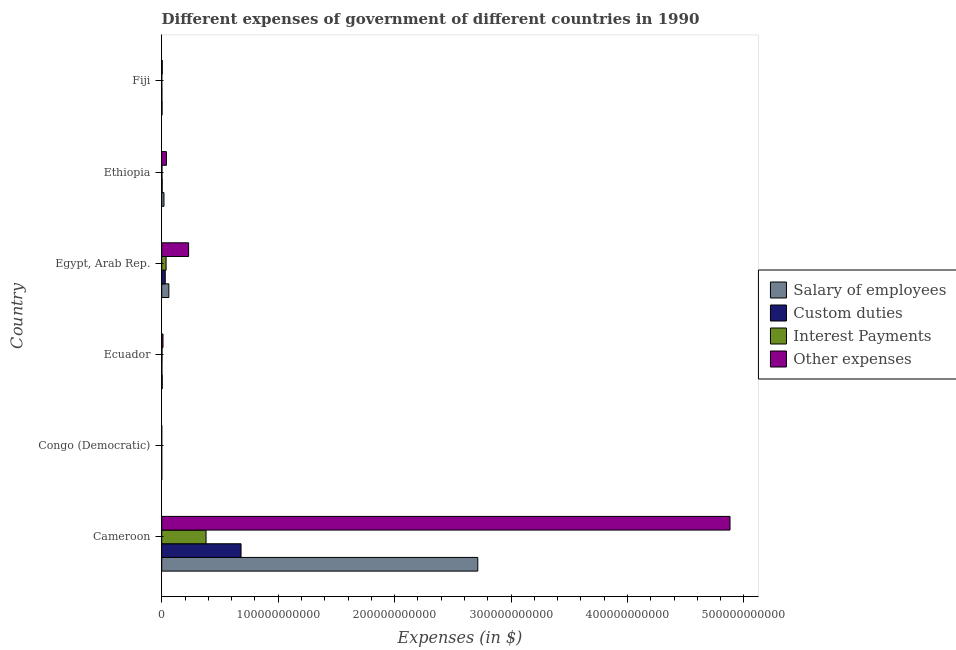Are the number of bars on each tick of the Y-axis equal?
Provide a succinct answer. Yes. What is the label of the 2nd group of bars from the top?
Your answer should be compact. Ethiopia. In how many cases, is the number of bars for a given country not equal to the number of legend labels?
Your answer should be very brief. 0. What is the amount spent on other expenses in Congo (Democratic)?
Keep it short and to the point. 3.74. Across all countries, what is the maximum amount spent on custom duties?
Offer a very short reply. 6.81e+1. Across all countries, what is the minimum amount spent on other expenses?
Your answer should be very brief. 3.74. In which country was the amount spent on custom duties maximum?
Ensure brevity in your answer.  Cameroon. In which country was the amount spent on interest payments minimum?
Offer a terse response. Congo (Democratic). What is the total amount spent on interest payments in the graph?
Your answer should be very brief. 4.24e+1. What is the difference between the amount spent on other expenses in Cameroon and that in Egypt, Arab Rep.?
Provide a short and direct response. 4.65e+11. What is the difference between the amount spent on custom duties in Ecuador and the amount spent on other expenses in Egypt, Arab Rep.?
Offer a very short reply. -2.29e+1. What is the average amount spent on other expenses per country?
Keep it short and to the point. 8.61e+1. What is the difference between the amount spent on custom duties and amount spent on interest payments in Ecuador?
Your response must be concise. -1.00e+08. What is the ratio of the amount spent on custom duties in Egypt, Arab Rep. to that in Fiji?
Offer a terse response. 19.52. Is the amount spent on salary of employees in Congo (Democratic) less than that in Egypt, Arab Rep.?
Your response must be concise. Yes. Is the difference between the amount spent on custom duties in Cameroon and Ethiopia greater than the difference between the amount spent on salary of employees in Cameroon and Ethiopia?
Keep it short and to the point. No. What is the difference between the highest and the second highest amount spent on custom duties?
Provide a short and direct response. 6.51e+1. What is the difference between the highest and the lowest amount spent on custom duties?
Your answer should be compact. 6.81e+1. What does the 4th bar from the top in Ecuador represents?
Provide a succinct answer. Salary of employees. What does the 3rd bar from the bottom in Ecuador represents?
Provide a short and direct response. Interest Payments. How many countries are there in the graph?
Provide a succinct answer. 6. What is the difference between two consecutive major ticks on the X-axis?
Offer a terse response. 1.00e+11. Are the values on the major ticks of X-axis written in scientific E-notation?
Your answer should be compact. No. What is the title of the graph?
Give a very brief answer. Different expenses of government of different countries in 1990. Does "Manufacturing" appear as one of the legend labels in the graph?
Offer a very short reply. No. What is the label or title of the X-axis?
Provide a succinct answer. Expenses (in $). What is the Expenses (in $) in Salary of employees in Cameroon?
Your answer should be very brief. 2.71e+11. What is the Expenses (in $) in Custom duties in Cameroon?
Offer a terse response. 6.81e+1. What is the Expenses (in $) of Interest Payments in Cameroon?
Keep it short and to the point. 3.81e+1. What is the Expenses (in $) of Other expenses in Cameroon?
Offer a terse response. 4.88e+11. What is the Expenses (in $) in Salary of employees in Congo (Democratic)?
Your answer should be compact. 0.95. What is the Expenses (in $) in Custom duties in Congo (Democratic)?
Ensure brevity in your answer.  0.95. What is the Expenses (in $) in Interest Payments in Congo (Democratic)?
Ensure brevity in your answer.  0.28. What is the Expenses (in $) of Other expenses in Congo (Democratic)?
Provide a short and direct response. 3.74. What is the Expenses (in $) in Salary of employees in Ecuador?
Your answer should be compact. 4.52e+08. What is the Expenses (in $) in Custom duties in Ecuador?
Ensure brevity in your answer.  1.76e+08. What is the Expenses (in $) of Interest Payments in Ecuador?
Give a very brief answer. 2.76e+08. What is the Expenses (in $) in Other expenses in Ecuador?
Give a very brief answer. 1.11e+09. What is the Expenses (in $) in Salary of employees in Egypt, Arab Rep.?
Your response must be concise. 6.14e+09. What is the Expenses (in $) of Custom duties in Egypt, Arab Rep.?
Offer a very short reply. 3.04e+09. What is the Expenses (in $) of Interest Payments in Egypt, Arab Rep.?
Offer a very short reply. 3.76e+09. What is the Expenses (in $) of Other expenses in Egypt, Arab Rep.?
Your answer should be very brief. 2.31e+1. What is the Expenses (in $) in Salary of employees in Ethiopia?
Make the answer very short. 1.95e+09. What is the Expenses (in $) of Custom duties in Ethiopia?
Your answer should be very brief. 3.91e+08. What is the Expenses (in $) of Interest Payments in Ethiopia?
Keep it short and to the point. 2.28e+08. What is the Expenses (in $) in Other expenses in Ethiopia?
Provide a short and direct response. 4.05e+09. What is the Expenses (in $) of Salary of employees in Fiji?
Provide a succinct answer. 3.04e+08. What is the Expenses (in $) of Custom duties in Fiji?
Your answer should be very brief. 1.56e+08. What is the Expenses (in $) of Interest Payments in Fiji?
Provide a short and direct response. 6.85e+07. What is the Expenses (in $) of Other expenses in Fiji?
Ensure brevity in your answer.  4.74e+08. Across all countries, what is the maximum Expenses (in $) in Salary of employees?
Your answer should be very brief. 2.71e+11. Across all countries, what is the maximum Expenses (in $) of Custom duties?
Provide a succinct answer. 6.81e+1. Across all countries, what is the maximum Expenses (in $) of Interest Payments?
Provide a short and direct response. 3.81e+1. Across all countries, what is the maximum Expenses (in $) of Other expenses?
Provide a succinct answer. 4.88e+11. Across all countries, what is the minimum Expenses (in $) of Salary of employees?
Your response must be concise. 0.95. Across all countries, what is the minimum Expenses (in $) in Custom duties?
Offer a very short reply. 0.95. Across all countries, what is the minimum Expenses (in $) in Interest Payments?
Give a very brief answer. 0.28. Across all countries, what is the minimum Expenses (in $) in Other expenses?
Your response must be concise. 3.74. What is the total Expenses (in $) in Salary of employees in the graph?
Offer a very short reply. 2.80e+11. What is the total Expenses (in $) in Custom duties in the graph?
Keep it short and to the point. 7.19e+1. What is the total Expenses (in $) in Interest Payments in the graph?
Make the answer very short. 4.24e+1. What is the total Expenses (in $) of Other expenses in the graph?
Your answer should be compact. 5.17e+11. What is the difference between the Expenses (in $) in Salary of employees in Cameroon and that in Congo (Democratic)?
Your answer should be very brief. 2.71e+11. What is the difference between the Expenses (in $) of Custom duties in Cameroon and that in Congo (Democratic)?
Offer a very short reply. 6.81e+1. What is the difference between the Expenses (in $) in Interest Payments in Cameroon and that in Congo (Democratic)?
Offer a very short reply. 3.81e+1. What is the difference between the Expenses (in $) of Other expenses in Cameroon and that in Congo (Democratic)?
Keep it short and to the point. 4.88e+11. What is the difference between the Expenses (in $) of Salary of employees in Cameroon and that in Ecuador?
Your response must be concise. 2.71e+11. What is the difference between the Expenses (in $) in Custom duties in Cameroon and that in Ecuador?
Your response must be concise. 6.80e+1. What is the difference between the Expenses (in $) of Interest Payments in Cameroon and that in Ecuador?
Provide a short and direct response. 3.78e+1. What is the difference between the Expenses (in $) in Other expenses in Cameroon and that in Ecuador?
Give a very brief answer. 4.87e+11. What is the difference between the Expenses (in $) of Salary of employees in Cameroon and that in Egypt, Arab Rep.?
Your answer should be compact. 2.65e+11. What is the difference between the Expenses (in $) of Custom duties in Cameroon and that in Egypt, Arab Rep.?
Provide a succinct answer. 6.51e+1. What is the difference between the Expenses (in $) of Interest Payments in Cameroon and that in Egypt, Arab Rep.?
Ensure brevity in your answer.  3.43e+1. What is the difference between the Expenses (in $) of Other expenses in Cameroon and that in Egypt, Arab Rep.?
Offer a very short reply. 4.65e+11. What is the difference between the Expenses (in $) in Salary of employees in Cameroon and that in Ethiopia?
Your response must be concise. 2.69e+11. What is the difference between the Expenses (in $) of Custom duties in Cameroon and that in Ethiopia?
Provide a short and direct response. 6.77e+1. What is the difference between the Expenses (in $) in Interest Payments in Cameroon and that in Ethiopia?
Give a very brief answer. 3.79e+1. What is the difference between the Expenses (in $) in Other expenses in Cameroon and that in Ethiopia?
Your answer should be compact. 4.84e+11. What is the difference between the Expenses (in $) of Salary of employees in Cameroon and that in Fiji?
Provide a succinct answer. 2.71e+11. What is the difference between the Expenses (in $) in Custom duties in Cameroon and that in Fiji?
Your answer should be compact. 6.80e+1. What is the difference between the Expenses (in $) of Interest Payments in Cameroon and that in Fiji?
Provide a succinct answer. 3.80e+1. What is the difference between the Expenses (in $) of Other expenses in Cameroon and that in Fiji?
Offer a terse response. 4.88e+11. What is the difference between the Expenses (in $) in Salary of employees in Congo (Democratic) and that in Ecuador?
Give a very brief answer. -4.52e+08. What is the difference between the Expenses (in $) in Custom duties in Congo (Democratic) and that in Ecuador?
Your answer should be very brief. -1.76e+08. What is the difference between the Expenses (in $) in Interest Payments in Congo (Democratic) and that in Ecuador?
Provide a succinct answer. -2.76e+08. What is the difference between the Expenses (in $) in Other expenses in Congo (Democratic) and that in Ecuador?
Your answer should be compact. -1.11e+09. What is the difference between the Expenses (in $) of Salary of employees in Congo (Democratic) and that in Egypt, Arab Rep.?
Provide a short and direct response. -6.13e+09. What is the difference between the Expenses (in $) in Custom duties in Congo (Democratic) and that in Egypt, Arab Rep.?
Keep it short and to the point. -3.04e+09. What is the difference between the Expenses (in $) of Interest Payments in Congo (Democratic) and that in Egypt, Arab Rep.?
Keep it short and to the point. -3.76e+09. What is the difference between the Expenses (in $) of Other expenses in Congo (Democratic) and that in Egypt, Arab Rep.?
Your answer should be compact. -2.31e+1. What is the difference between the Expenses (in $) in Salary of employees in Congo (Democratic) and that in Ethiopia?
Your response must be concise. -1.95e+09. What is the difference between the Expenses (in $) in Custom duties in Congo (Democratic) and that in Ethiopia?
Offer a very short reply. -3.91e+08. What is the difference between the Expenses (in $) of Interest Payments in Congo (Democratic) and that in Ethiopia?
Your answer should be compact. -2.28e+08. What is the difference between the Expenses (in $) of Other expenses in Congo (Democratic) and that in Ethiopia?
Provide a succinct answer. -4.05e+09. What is the difference between the Expenses (in $) of Salary of employees in Congo (Democratic) and that in Fiji?
Make the answer very short. -3.04e+08. What is the difference between the Expenses (in $) in Custom duties in Congo (Democratic) and that in Fiji?
Give a very brief answer. -1.56e+08. What is the difference between the Expenses (in $) in Interest Payments in Congo (Democratic) and that in Fiji?
Offer a terse response. -6.85e+07. What is the difference between the Expenses (in $) of Other expenses in Congo (Democratic) and that in Fiji?
Offer a terse response. -4.74e+08. What is the difference between the Expenses (in $) in Salary of employees in Ecuador and that in Egypt, Arab Rep.?
Make the answer very short. -5.68e+09. What is the difference between the Expenses (in $) of Custom duties in Ecuador and that in Egypt, Arab Rep.?
Your answer should be compact. -2.86e+09. What is the difference between the Expenses (in $) in Interest Payments in Ecuador and that in Egypt, Arab Rep.?
Make the answer very short. -3.48e+09. What is the difference between the Expenses (in $) of Other expenses in Ecuador and that in Egypt, Arab Rep.?
Your answer should be very brief. -2.20e+1. What is the difference between the Expenses (in $) in Salary of employees in Ecuador and that in Ethiopia?
Your answer should be compact. -1.50e+09. What is the difference between the Expenses (in $) in Custom duties in Ecuador and that in Ethiopia?
Your answer should be very brief. -2.15e+08. What is the difference between the Expenses (in $) in Interest Payments in Ecuador and that in Ethiopia?
Give a very brief answer. 4.83e+07. What is the difference between the Expenses (in $) of Other expenses in Ecuador and that in Ethiopia?
Your answer should be very brief. -2.94e+09. What is the difference between the Expenses (in $) of Salary of employees in Ecuador and that in Fiji?
Make the answer very short. 1.48e+08. What is the difference between the Expenses (in $) of Custom duties in Ecuador and that in Fiji?
Offer a terse response. 2.04e+07. What is the difference between the Expenses (in $) of Interest Payments in Ecuador and that in Fiji?
Your answer should be very brief. 2.07e+08. What is the difference between the Expenses (in $) in Other expenses in Ecuador and that in Fiji?
Ensure brevity in your answer.  6.37e+08. What is the difference between the Expenses (in $) of Salary of employees in Egypt, Arab Rep. and that in Ethiopia?
Ensure brevity in your answer.  4.18e+09. What is the difference between the Expenses (in $) of Custom duties in Egypt, Arab Rep. and that in Ethiopia?
Your response must be concise. 2.65e+09. What is the difference between the Expenses (in $) of Interest Payments in Egypt, Arab Rep. and that in Ethiopia?
Keep it short and to the point. 3.53e+09. What is the difference between the Expenses (in $) in Other expenses in Egypt, Arab Rep. and that in Ethiopia?
Your answer should be very brief. 1.90e+1. What is the difference between the Expenses (in $) in Salary of employees in Egypt, Arab Rep. and that in Fiji?
Your answer should be very brief. 5.83e+09. What is the difference between the Expenses (in $) of Custom duties in Egypt, Arab Rep. and that in Fiji?
Make the answer very short. 2.88e+09. What is the difference between the Expenses (in $) of Interest Payments in Egypt, Arab Rep. and that in Fiji?
Ensure brevity in your answer.  3.69e+09. What is the difference between the Expenses (in $) of Other expenses in Egypt, Arab Rep. and that in Fiji?
Offer a very short reply. 2.26e+1. What is the difference between the Expenses (in $) of Salary of employees in Ethiopia and that in Fiji?
Offer a very short reply. 1.65e+09. What is the difference between the Expenses (in $) of Custom duties in Ethiopia and that in Fiji?
Keep it short and to the point. 2.36e+08. What is the difference between the Expenses (in $) in Interest Payments in Ethiopia and that in Fiji?
Offer a very short reply. 1.59e+08. What is the difference between the Expenses (in $) in Other expenses in Ethiopia and that in Fiji?
Offer a very short reply. 3.58e+09. What is the difference between the Expenses (in $) of Salary of employees in Cameroon and the Expenses (in $) of Custom duties in Congo (Democratic)?
Keep it short and to the point. 2.71e+11. What is the difference between the Expenses (in $) in Salary of employees in Cameroon and the Expenses (in $) in Interest Payments in Congo (Democratic)?
Keep it short and to the point. 2.71e+11. What is the difference between the Expenses (in $) in Salary of employees in Cameroon and the Expenses (in $) in Other expenses in Congo (Democratic)?
Keep it short and to the point. 2.71e+11. What is the difference between the Expenses (in $) in Custom duties in Cameroon and the Expenses (in $) in Interest Payments in Congo (Democratic)?
Give a very brief answer. 6.81e+1. What is the difference between the Expenses (in $) in Custom duties in Cameroon and the Expenses (in $) in Other expenses in Congo (Democratic)?
Your response must be concise. 6.81e+1. What is the difference between the Expenses (in $) in Interest Payments in Cameroon and the Expenses (in $) in Other expenses in Congo (Democratic)?
Offer a terse response. 3.81e+1. What is the difference between the Expenses (in $) of Salary of employees in Cameroon and the Expenses (in $) of Custom duties in Ecuador?
Ensure brevity in your answer.  2.71e+11. What is the difference between the Expenses (in $) in Salary of employees in Cameroon and the Expenses (in $) in Interest Payments in Ecuador?
Your answer should be very brief. 2.71e+11. What is the difference between the Expenses (in $) of Salary of employees in Cameroon and the Expenses (in $) of Other expenses in Ecuador?
Your answer should be compact. 2.70e+11. What is the difference between the Expenses (in $) in Custom duties in Cameroon and the Expenses (in $) in Interest Payments in Ecuador?
Your answer should be very brief. 6.79e+1. What is the difference between the Expenses (in $) of Custom duties in Cameroon and the Expenses (in $) of Other expenses in Ecuador?
Offer a very short reply. 6.70e+1. What is the difference between the Expenses (in $) in Interest Payments in Cameroon and the Expenses (in $) in Other expenses in Ecuador?
Your response must be concise. 3.70e+1. What is the difference between the Expenses (in $) in Salary of employees in Cameroon and the Expenses (in $) in Custom duties in Egypt, Arab Rep.?
Offer a terse response. 2.68e+11. What is the difference between the Expenses (in $) of Salary of employees in Cameroon and the Expenses (in $) of Interest Payments in Egypt, Arab Rep.?
Provide a short and direct response. 2.68e+11. What is the difference between the Expenses (in $) in Salary of employees in Cameroon and the Expenses (in $) in Other expenses in Egypt, Arab Rep.?
Offer a terse response. 2.48e+11. What is the difference between the Expenses (in $) in Custom duties in Cameroon and the Expenses (in $) in Interest Payments in Egypt, Arab Rep.?
Offer a very short reply. 6.44e+1. What is the difference between the Expenses (in $) in Custom duties in Cameroon and the Expenses (in $) in Other expenses in Egypt, Arab Rep.?
Make the answer very short. 4.50e+1. What is the difference between the Expenses (in $) of Interest Payments in Cameroon and the Expenses (in $) of Other expenses in Egypt, Arab Rep.?
Ensure brevity in your answer.  1.50e+1. What is the difference between the Expenses (in $) of Salary of employees in Cameroon and the Expenses (in $) of Custom duties in Ethiopia?
Offer a terse response. 2.71e+11. What is the difference between the Expenses (in $) in Salary of employees in Cameroon and the Expenses (in $) in Interest Payments in Ethiopia?
Provide a succinct answer. 2.71e+11. What is the difference between the Expenses (in $) of Salary of employees in Cameroon and the Expenses (in $) of Other expenses in Ethiopia?
Give a very brief answer. 2.67e+11. What is the difference between the Expenses (in $) of Custom duties in Cameroon and the Expenses (in $) of Interest Payments in Ethiopia?
Offer a terse response. 6.79e+1. What is the difference between the Expenses (in $) of Custom duties in Cameroon and the Expenses (in $) of Other expenses in Ethiopia?
Give a very brief answer. 6.41e+1. What is the difference between the Expenses (in $) of Interest Payments in Cameroon and the Expenses (in $) of Other expenses in Ethiopia?
Provide a succinct answer. 3.40e+1. What is the difference between the Expenses (in $) of Salary of employees in Cameroon and the Expenses (in $) of Custom duties in Fiji?
Your answer should be very brief. 2.71e+11. What is the difference between the Expenses (in $) of Salary of employees in Cameroon and the Expenses (in $) of Interest Payments in Fiji?
Offer a terse response. 2.71e+11. What is the difference between the Expenses (in $) of Salary of employees in Cameroon and the Expenses (in $) of Other expenses in Fiji?
Keep it short and to the point. 2.71e+11. What is the difference between the Expenses (in $) in Custom duties in Cameroon and the Expenses (in $) in Interest Payments in Fiji?
Ensure brevity in your answer.  6.81e+1. What is the difference between the Expenses (in $) of Custom duties in Cameroon and the Expenses (in $) of Other expenses in Fiji?
Offer a terse response. 6.77e+1. What is the difference between the Expenses (in $) of Interest Payments in Cameroon and the Expenses (in $) of Other expenses in Fiji?
Offer a terse response. 3.76e+1. What is the difference between the Expenses (in $) in Salary of employees in Congo (Democratic) and the Expenses (in $) in Custom duties in Ecuador?
Ensure brevity in your answer.  -1.76e+08. What is the difference between the Expenses (in $) of Salary of employees in Congo (Democratic) and the Expenses (in $) of Interest Payments in Ecuador?
Your response must be concise. -2.76e+08. What is the difference between the Expenses (in $) of Salary of employees in Congo (Democratic) and the Expenses (in $) of Other expenses in Ecuador?
Offer a terse response. -1.11e+09. What is the difference between the Expenses (in $) of Custom duties in Congo (Democratic) and the Expenses (in $) of Interest Payments in Ecuador?
Provide a succinct answer. -2.76e+08. What is the difference between the Expenses (in $) in Custom duties in Congo (Democratic) and the Expenses (in $) in Other expenses in Ecuador?
Provide a short and direct response. -1.11e+09. What is the difference between the Expenses (in $) of Interest Payments in Congo (Democratic) and the Expenses (in $) of Other expenses in Ecuador?
Your answer should be compact. -1.11e+09. What is the difference between the Expenses (in $) in Salary of employees in Congo (Democratic) and the Expenses (in $) in Custom duties in Egypt, Arab Rep.?
Offer a terse response. -3.04e+09. What is the difference between the Expenses (in $) of Salary of employees in Congo (Democratic) and the Expenses (in $) of Interest Payments in Egypt, Arab Rep.?
Offer a terse response. -3.76e+09. What is the difference between the Expenses (in $) in Salary of employees in Congo (Democratic) and the Expenses (in $) in Other expenses in Egypt, Arab Rep.?
Provide a short and direct response. -2.31e+1. What is the difference between the Expenses (in $) of Custom duties in Congo (Democratic) and the Expenses (in $) of Interest Payments in Egypt, Arab Rep.?
Give a very brief answer. -3.76e+09. What is the difference between the Expenses (in $) in Custom duties in Congo (Democratic) and the Expenses (in $) in Other expenses in Egypt, Arab Rep.?
Your answer should be compact. -2.31e+1. What is the difference between the Expenses (in $) in Interest Payments in Congo (Democratic) and the Expenses (in $) in Other expenses in Egypt, Arab Rep.?
Offer a very short reply. -2.31e+1. What is the difference between the Expenses (in $) of Salary of employees in Congo (Democratic) and the Expenses (in $) of Custom duties in Ethiopia?
Provide a succinct answer. -3.91e+08. What is the difference between the Expenses (in $) in Salary of employees in Congo (Democratic) and the Expenses (in $) in Interest Payments in Ethiopia?
Provide a succinct answer. -2.28e+08. What is the difference between the Expenses (in $) of Salary of employees in Congo (Democratic) and the Expenses (in $) of Other expenses in Ethiopia?
Offer a terse response. -4.05e+09. What is the difference between the Expenses (in $) of Custom duties in Congo (Democratic) and the Expenses (in $) of Interest Payments in Ethiopia?
Give a very brief answer. -2.28e+08. What is the difference between the Expenses (in $) in Custom duties in Congo (Democratic) and the Expenses (in $) in Other expenses in Ethiopia?
Your answer should be very brief. -4.05e+09. What is the difference between the Expenses (in $) in Interest Payments in Congo (Democratic) and the Expenses (in $) in Other expenses in Ethiopia?
Keep it short and to the point. -4.05e+09. What is the difference between the Expenses (in $) of Salary of employees in Congo (Democratic) and the Expenses (in $) of Custom duties in Fiji?
Make the answer very short. -1.56e+08. What is the difference between the Expenses (in $) in Salary of employees in Congo (Democratic) and the Expenses (in $) in Interest Payments in Fiji?
Your response must be concise. -6.85e+07. What is the difference between the Expenses (in $) in Salary of employees in Congo (Democratic) and the Expenses (in $) in Other expenses in Fiji?
Offer a terse response. -4.74e+08. What is the difference between the Expenses (in $) in Custom duties in Congo (Democratic) and the Expenses (in $) in Interest Payments in Fiji?
Provide a short and direct response. -6.85e+07. What is the difference between the Expenses (in $) in Custom duties in Congo (Democratic) and the Expenses (in $) in Other expenses in Fiji?
Provide a succinct answer. -4.74e+08. What is the difference between the Expenses (in $) in Interest Payments in Congo (Democratic) and the Expenses (in $) in Other expenses in Fiji?
Provide a short and direct response. -4.74e+08. What is the difference between the Expenses (in $) in Salary of employees in Ecuador and the Expenses (in $) in Custom duties in Egypt, Arab Rep.?
Provide a short and direct response. -2.58e+09. What is the difference between the Expenses (in $) of Salary of employees in Ecuador and the Expenses (in $) of Interest Payments in Egypt, Arab Rep.?
Ensure brevity in your answer.  -3.31e+09. What is the difference between the Expenses (in $) in Salary of employees in Ecuador and the Expenses (in $) in Other expenses in Egypt, Arab Rep.?
Your answer should be very brief. -2.26e+1. What is the difference between the Expenses (in $) of Custom duties in Ecuador and the Expenses (in $) of Interest Payments in Egypt, Arab Rep.?
Offer a very short reply. -3.58e+09. What is the difference between the Expenses (in $) in Custom duties in Ecuador and the Expenses (in $) in Other expenses in Egypt, Arab Rep.?
Make the answer very short. -2.29e+1. What is the difference between the Expenses (in $) of Interest Payments in Ecuador and the Expenses (in $) of Other expenses in Egypt, Arab Rep.?
Your answer should be very brief. -2.28e+1. What is the difference between the Expenses (in $) of Salary of employees in Ecuador and the Expenses (in $) of Custom duties in Ethiopia?
Your answer should be compact. 6.07e+07. What is the difference between the Expenses (in $) in Salary of employees in Ecuador and the Expenses (in $) in Interest Payments in Ethiopia?
Keep it short and to the point. 2.24e+08. What is the difference between the Expenses (in $) of Salary of employees in Ecuador and the Expenses (in $) of Other expenses in Ethiopia?
Your answer should be compact. -3.60e+09. What is the difference between the Expenses (in $) in Custom duties in Ecuador and the Expenses (in $) in Interest Payments in Ethiopia?
Your response must be concise. -5.17e+07. What is the difference between the Expenses (in $) of Custom duties in Ecuador and the Expenses (in $) of Other expenses in Ethiopia?
Keep it short and to the point. -3.88e+09. What is the difference between the Expenses (in $) in Interest Payments in Ecuador and the Expenses (in $) in Other expenses in Ethiopia?
Your answer should be very brief. -3.78e+09. What is the difference between the Expenses (in $) of Salary of employees in Ecuador and the Expenses (in $) of Custom duties in Fiji?
Offer a terse response. 2.96e+08. What is the difference between the Expenses (in $) of Salary of employees in Ecuador and the Expenses (in $) of Interest Payments in Fiji?
Ensure brevity in your answer.  3.83e+08. What is the difference between the Expenses (in $) in Salary of employees in Ecuador and the Expenses (in $) in Other expenses in Fiji?
Ensure brevity in your answer.  -2.23e+07. What is the difference between the Expenses (in $) of Custom duties in Ecuador and the Expenses (in $) of Interest Payments in Fiji?
Your response must be concise. 1.07e+08. What is the difference between the Expenses (in $) of Custom duties in Ecuador and the Expenses (in $) of Other expenses in Fiji?
Offer a terse response. -2.98e+08. What is the difference between the Expenses (in $) of Interest Payments in Ecuador and the Expenses (in $) of Other expenses in Fiji?
Offer a very short reply. -1.98e+08. What is the difference between the Expenses (in $) in Salary of employees in Egypt, Arab Rep. and the Expenses (in $) in Custom duties in Ethiopia?
Keep it short and to the point. 5.74e+09. What is the difference between the Expenses (in $) of Salary of employees in Egypt, Arab Rep. and the Expenses (in $) of Interest Payments in Ethiopia?
Provide a succinct answer. 5.91e+09. What is the difference between the Expenses (in $) of Salary of employees in Egypt, Arab Rep. and the Expenses (in $) of Other expenses in Ethiopia?
Your answer should be compact. 2.08e+09. What is the difference between the Expenses (in $) of Custom duties in Egypt, Arab Rep. and the Expenses (in $) of Interest Payments in Ethiopia?
Make the answer very short. 2.81e+09. What is the difference between the Expenses (in $) in Custom duties in Egypt, Arab Rep. and the Expenses (in $) in Other expenses in Ethiopia?
Ensure brevity in your answer.  -1.02e+09. What is the difference between the Expenses (in $) in Interest Payments in Egypt, Arab Rep. and the Expenses (in $) in Other expenses in Ethiopia?
Give a very brief answer. -2.94e+08. What is the difference between the Expenses (in $) in Salary of employees in Egypt, Arab Rep. and the Expenses (in $) in Custom duties in Fiji?
Offer a terse response. 5.98e+09. What is the difference between the Expenses (in $) in Salary of employees in Egypt, Arab Rep. and the Expenses (in $) in Interest Payments in Fiji?
Keep it short and to the point. 6.07e+09. What is the difference between the Expenses (in $) of Salary of employees in Egypt, Arab Rep. and the Expenses (in $) of Other expenses in Fiji?
Offer a terse response. 5.66e+09. What is the difference between the Expenses (in $) of Custom duties in Egypt, Arab Rep. and the Expenses (in $) of Interest Payments in Fiji?
Ensure brevity in your answer.  2.97e+09. What is the difference between the Expenses (in $) in Custom duties in Egypt, Arab Rep. and the Expenses (in $) in Other expenses in Fiji?
Provide a short and direct response. 2.56e+09. What is the difference between the Expenses (in $) in Interest Payments in Egypt, Arab Rep. and the Expenses (in $) in Other expenses in Fiji?
Keep it short and to the point. 3.29e+09. What is the difference between the Expenses (in $) of Salary of employees in Ethiopia and the Expenses (in $) of Custom duties in Fiji?
Keep it short and to the point. 1.79e+09. What is the difference between the Expenses (in $) of Salary of employees in Ethiopia and the Expenses (in $) of Interest Payments in Fiji?
Give a very brief answer. 1.88e+09. What is the difference between the Expenses (in $) in Salary of employees in Ethiopia and the Expenses (in $) in Other expenses in Fiji?
Provide a succinct answer. 1.48e+09. What is the difference between the Expenses (in $) in Custom duties in Ethiopia and the Expenses (in $) in Interest Payments in Fiji?
Provide a short and direct response. 3.23e+08. What is the difference between the Expenses (in $) in Custom duties in Ethiopia and the Expenses (in $) in Other expenses in Fiji?
Ensure brevity in your answer.  -8.30e+07. What is the difference between the Expenses (in $) in Interest Payments in Ethiopia and the Expenses (in $) in Other expenses in Fiji?
Your answer should be very brief. -2.47e+08. What is the average Expenses (in $) of Salary of employees per country?
Give a very brief answer. 4.67e+1. What is the average Expenses (in $) of Custom duties per country?
Give a very brief answer. 1.20e+1. What is the average Expenses (in $) in Interest Payments per country?
Offer a terse response. 7.07e+09. What is the average Expenses (in $) of Other expenses per country?
Make the answer very short. 8.61e+1. What is the difference between the Expenses (in $) of Salary of employees and Expenses (in $) of Custom duties in Cameroon?
Make the answer very short. 2.03e+11. What is the difference between the Expenses (in $) of Salary of employees and Expenses (in $) of Interest Payments in Cameroon?
Provide a short and direct response. 2.33e+11. What is the difference between the Expenses (in $) in Salary of employees and Expenses (in $) in Other expenses in Cameroon?
Make the answer very short. -2.17e+11. What is the difference between the Expenses (in $) of Custom duties and Expenses (in $) of Interest Payments in Cameroon?
Provide a short and direct response. 3.01e+1. What is the difference between the Expenses (in $) of Custom duties and Expenses (in $) of Other expenses in Cameroon?
Provide a short and direct response. -4.20e+11. What is the difference between the Expenses (in $) of Interest Payments and Expenses (in $) of Other expenses in Cameroon?
Offer a terse response. -4.50e+11. What is the difference between the Expenses (in $) in Salary of employees and Expenses (in $) in Custom duties in Congo (Democratic)?
Offer a terse response. -0. What is the difference between the Expenses (in $) of Salary of employees and Expenses (in $) of Interest Payments in Congo (Democratic)?
Provide a short and direct response. 0.67. What is the difference between the Expenses (in $) of Salary of employees and Expenses (in $) of Other expenses in Congo (Democratic)?
Offer a terse response. -2.79. What is the difference between the Expenses (in $) of Custom duties and Expenses (in $) of Interest Payments in Congo (Democratic)?
Provide a short and direct response. 0.67. What is the difference between the Expenses (in $) of Custom duties and Expenses (in $) of Other expenses in Congo (Democratic)?
Offer a very short reply. -2.79. What is the difference between the Expenses (in $) in Interest Payments and Expenses (in $) in Other expenses in Congo (Democratic)?
Your answer should be compact. -3.46. What is the difference between the Expenses (in $) of Salary of employees and Expenses (in $) of Custom duties in Ecuador?
Ensure brevity in your answer.  2.76e+08. What is the difference between the Expenses (in $) of Salary of employees and Expenses (in $) of Interest Payments in Ecuador?
Give a very brief answer. 1.76e+08. What is the difference between the Expenses (in $) of Salary of employees and Expenses (in $) of Other expenses in Ecuador?
Offer a very short reply. -6.59e+08. What is the difference between the Expenses (in $) of Custom duties and Expenses (in $) of Interest Payments in Ecuador?
Keep it short and to the point. -1.00e+08. What is the difference between the Expenses (in $) of Custom duties and Expenses (in $) of Other expenses in Ecuador?
Provide a succinct answer. -9.35e+08. What is the difference between the Expenses (in $) of Interest Payments and Expenses (in $) of Other expenses in Ecuador?
Keep it short and to the point. -8.35e+08. What is the difference between the Expenses (in $) in Salary of employees and Expenses (in $) in Custom duties in Egypt, Arab Rep.?
Make the answer very short. 3.10e+09. What is the difference between the Expenses (in $) of Salary of employees and Expenses (in $) of Interest Payments in Egypt, Arab Rep.?
Give a very brief answer. 2.38e+09. What is the difference between the Expenses (in $) of Salary of employees and Expenses (in $) of Other expenses in Egypt, Arab Rep.?
Provide a short and direct response. -1.70e+1. What is the difference between the Expenses (in $) of Custom duties and Expenses (in $) of Interest Payments in Egypt, Arab Rep.?
Offer a very short reply. -7.23e+08. What is the difference between the Expenses (in $) of Custom duties and Expenses (in $) of Other expenses in Egypt, Arab Rep.?
Keep it short and to the point. -2.01e+1. What is the difference between the Expenses (in $) of Interest Payments and Expenses (in $) of Other expenses in Egypt, Arab Rep.?
Make the answer very short. -1.93e+1. What is the difference between the Expenses (in $) in Salary of employees and Expenses (in $) in Custom duties in Ethiopia?
Your answer should be very brief. 1.56e+09. What is the difference between the Expenses (in $) in Salary of employees and Expenses (in $) in Interest Payments in Ethiopia?
Your answer should be compact. 1.72e+09. What is the difference between the Expenses (in $) in Salary of employees and Expenses (in $) in Other expenses in Ethiopia?
Provide a short and direct response. -2.10e+09. What is the difference between the Expenses (in $) of Custom duties and Expenses (in $) of Interest Payments in Ethiopia?
Your answer should be compact. 1.64e+08. What is the difference between the Expenses (in $) in Custom duties and Expenses (in $) in Other expenses in Ethiopia?
Offer a very short reply. -3.66e+09. What is the difference between the Expenses (in $) in Interest Payments and Expenses (in $) in Other expenses in Ethiopia?
Your response must be concise. -3.83e+09. What is the difference between the Expenses (in $) of Salary of employees and Expenses (in $) of Custom duties in Fiji?
Keep it short and to the point. 1.48e+08. What is the difference between the Expenses (in $) of Salary of employees and Expenses (in $) of Interest Payments in Fiji?
Give a very brief answer. 2.35e+08. What is the difference between the Expenses (in $) in Salary of employees and Expenses (in $) in Other expenses in Fiji?
Your response must be concise. -1.71e+08. What is the difference between the Expenses (in $) in Custom duties and Expenses (in $) in Interest Payments in Fiji?
Ensure brevity in your answer.  8.71e+07. What is the difference between the Expenses (in $) of Custom duties and Expenses (in $) of Other expenses in Fiji?
Offer a terse response. -3.19e+08. What is the difference between the Expenses (in $) in Interest Payments and Expenses (in $) in Other expenses in Fiji?
Ensure brevity in your answer.  -4.06e+08. What is the ratio of the Expenses (in $) of Salary of employees in Cameroon to that in Congo (Democratic)?
Make the answer very short. 2.86e+11. What is the ratio of the Expenses (in $) of Custom duties in Cameroon to that in Congo (Democratic)?
Your answer should be compact. 7.18e+1. What is the ratio of the Expenses (in $) in Interest Payments in Cameroon to that in Congo (Democratic)?
Provide a short and direct response. 1.38e+11. What is the ratio of the Expenses (in $) in Other expenses in Cameroon to that in Congo (Democratic)?
Provide a succinct answer. 1.31e+11. What is the ratio of the Expenses (in $) of Salary of employees in Cameroon to that in Ecuador?
Keep it short and to the point. 600.53. What is the ratio of the Expenses (in $) of Custom duties in Cameroon to that in Ecuador?
Provide a short and direct response. 387.16. What is the ratio of the Expenses (in $) in Interest Payments in Cameroon to that in Ecuador?
Make the answer very short. 137.97. What is the ratio of the Expenses (in $) of Other expenses in Cameroon to that in Ecuador?
Your answer should be very brief. 439.3. What is the ratio of the Expenses (in $) of Salary of employees in Cameroon to that in Egypt, Arab Rep.?
Make the answer very short. 44.24. What is the ratio of the Expenses (in $) of Custom duties in Cameroon to that in Egypt, Arab Rep.?
Make the answer very short. 22.44. What is the ratio of the Expenses (in $) of Interest Payments in Cameroon to that in Egypt, Arab Rep.?
Offer a very short reply. 10.13. What is the ratio of the Expenses (in $) of Other expenses in Cameroon to that in Egypt, Arab Rep.?
Give a very brief answer. 21.13. What is the ratio of the Expenses (in $) in Salary of employees in Cameroon to that in Ethiopia?
Your answer should be compact. 139.16. What is the ratio of the Expenses (in $) in Custom duties in Cameroon to that in Ethiopia?
Offer a very short reply. 174.14. What is the ratio of the Expenses (in $) in Interest Payments in Cameroon to that in Ethiopia?
Give a very brief answer. 167.24. What is the ratio of the Expenses (in $) of Other expenses in Cameroon to that in Ethiopia?
Your answer should be compact. 120.39. What is the ratio of the Expenses (in $) of Salary of employees in Cameroon to that in Fiji?
Offer a terse response. 893.69. What is the ratio of the Expenses (in $) in Custom duties in Cameroon to that in Fiji?
Your response must be concise. 438. What is the ratio of the Expenses (in $) in Interest Payments in Cameroon to that in Fiji?
Your answer should be compact. 555.83. What is the ratio of the Expenses (in $) in Other expenses in Cameroon to that in Fiji?
Give a very brief answer. 1028.92. What is the ratio of the Expenses (in $) in Custom duties in Congo (Democratic) to that in Ecuador?
Your response must be concise. 0. What is the ratio of the Expenses (in $) of Other expenses in Congo (Democratic) to that in Ecuador?
Provide a short and direct response. 0. What is the ratio of the Expenses (in $) in Salary of employees in Congo (Democratic) to that in Egypt, Arab Rep.?
Offer a very short reply. 0. What is the ratio of the Expenses (in $) of Interest Payments in Congo (Democratic) to that in Egypt, Arab Rep.?
Ensure brevity in your answer.  0. What is the ratio of the Expenses (in $) of Other expenses in Congo (Democratic) to that in Egypt, Arab Rep.?
Give a very brief answer. 0. What is the ratio of the Expenses (in $) in Custom duties in Congo (Democratic) to that in Ethiopia?
Provide a succinct answer. 0. What is the ratio of the Expenses (in $) in Salary of employees in Congo (Democratic) to that in Fiji?
Offer a very short reply. 0. What is the ratio of the Expenses (in $) of Custom duties in Congo (Democratic) to that in Fiji?
Your response must be concise. 0. What is the ratio of the Expenses (in $) in Salary of employees in Ecuador to that in Egypt, Arab Rep.?
Ensure brevity in your answer.  0.07. What is the ratio of the Expenses (in $) of Custom duties in Ecuador to that in Egypt, Arab Rep.?
Your answer should be very brief. 0.06. What is the ratio of the Expenses (in $) of Interest Payments in Ecuador to that in Egypt, Arab Rep.?
Offer a very short reply. 0.07. What is the ratio of the Expenses (in $) of Other expenses in Ecuador to that in Egypt, Arab Rep.?
Offer a very short reply. 0.05. What is the ratio of the Expenses (in $) in Salary of employees in Ecuador to that in Ethiopia?
Offer a very short reply. 0.23. What is the ratio of the Expenses (in $) in Custom duties in Ecuador to that in Ethiopia?
Keep it short and to the point. 0.45. What is the ratio of the Expenses (in $) in Interest Payments in Ecuador to that in Ethiopia?
Offer a terse response. 1.21. What is the ratio of the Expenses (in $) in Other expenses in Ecuador to that in Ethiopia?
Make the answer very short. 0.27. What is the ratio of the Expenses (in $) in Salary of employees in Ecuador to that in Fiji?
Your answer should be compact. 1.49. What is the ratio of the Expenses (in $) in Custom duties in Ecuador to that in Fiji?
Your answer should be compact. 1.13. What is the ratio of the Expenses (in $) in Interest Payments in Ecuador to that in Fiji?
Your response must be concise. 4.03. What is the ratio of the Expenses (in $) of Other expenses in Ecuador to that in Fiji?
Keep it short and to the point. 2.34. What is the ratio of the Expenses (in $) of Salary of employees in Egypt, Arab Rep. to that in Ethiopia?
Ensure brevity in your answer.  3.15. What is the ratio of the Expenses (in $) of Custom duties in Egypt, Arab Rep. to that in Ethiopia?
Give a very brief answer. 7.76. What is the ratio of the Expenses (in $) in Interest Payments in Egypt, Arab Rep. to that in Ethiopia?
Your answer should be very brief. 16.51. What is the ratio of the Expenses (in $) of Other expenses in Egypt, Arab Rep. to that in Ethiopia?
Offer a very short reply. 5.7. What is the ratio of the Expenses (in $) of Salary of employees in Egypt, Arab Rep. to that in Fiji?
Ensure brevity in your answer.  20.2. What is the ratio of the Expenses (in $) in Custom duties in Egypt, Arab Rep. to that in Fiji?
Ensure brevity in your answer.  19.52. What is the ratio of the Expenses (in $) of Interest Payments in Egypt, Arab Rep. to that in Fiji?
Give a very brief answer. 54.88. What is the ratio of the Expenses (in $) in Other expenses in Egypt, Arab Rep. to that in Fiji?
Keep it short and to the point. 48.7. What is the ratio of the Expenses (in $) in Salary of employees in Ethiopia to that in Fiji?
Give a very brief answer. 6.42. What is the ratio of the Expenses (in $) of Custom duties in Ethiopia to that in Fiji?
Provide a succinct answer. 2.52. What is the ratio of the Expenses (in $) of Interest Payments in Ethiopia to that in Fiji?
Keep it short and to the point. 3.32. What is the ratio of the Expenses (in $) of Other expenses in Ethiopia to that in Fiji?
Provide a short and direct response. 8.55. What is the difference between the highest and the second highest Expenses (in $) of Salary of employees?
Give a very brief answer. 2.65e+11. What is the difference between the highest and the second highest Expenses (in $) in Custom duties?
Make the answer very short. 6.51e+1. What is the difference between the highest and the second highest Expenses (in $) in Interest Payments?
Provide a succinct answer. 3.43e+1. What is the difference between the highest and the second highest Expenses (in $) of Other expenses?
Make the answer very short. 4.65e+11. What is the difference between the highest and the lowest Expenses (in $) in Salary of employees?
Your answer should be compact. 2.71e+11. What is the difference between the highest and the lowest Expenses (in $) in Custom duties?
Your answer should be very brief. 6.81e+1. What is the difference between the highest and the lowest Expenses (in $) in Interest Payments?
Provide a short and direct response. 3.81e+1. What is the difference between the highest and the lowest Expenses (in $) of Other expenses?
Provide a short and direct response. 4.88e+11. 